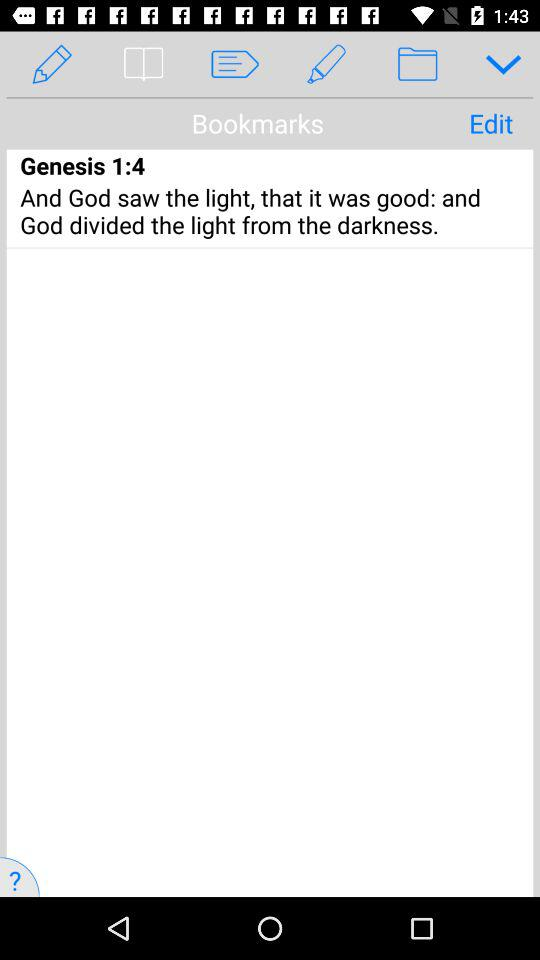The excerpt is the part of which Genesis?
When the provided information is insufficient, respond with <no answer>. <no answer> 